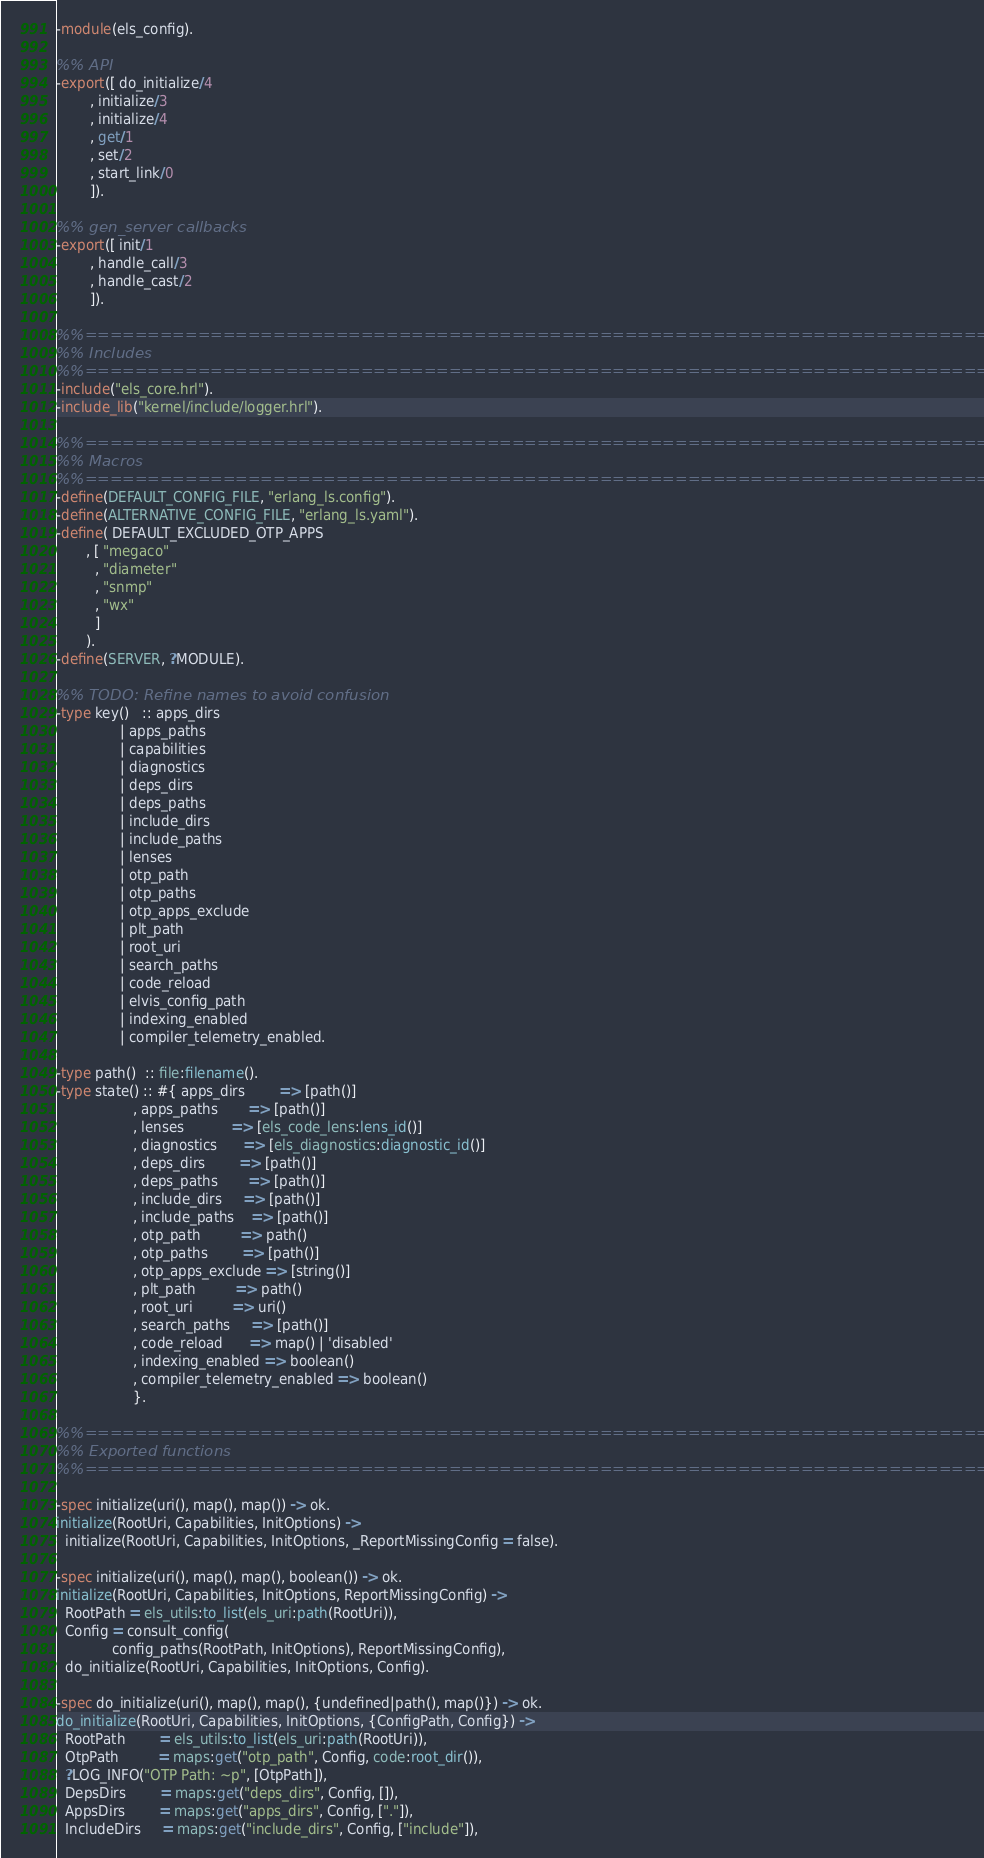Convert code to text. <code><loc_0><loc_0><loc_500><loc_500><_Erlang_>-module(els_config).

%% API
-export([ do_initialize/4
        , initialize/3
        , initialize/4
        , get/1
        , set/2
        , start_link/0
        ]).

%% gen_server callbacks
-export([ init/1
        , handle_call/3
        , handle_cast/2
        ]).

%%==============================================================================
%% Includes
%%==============================================================================
-include("els_core.hrl").
-include_lib("kernel/include/logger.hrl").

%%==============================================================================
%% Macros
%%==============================================================================
-define(DEFAULT_CONFIG_FILE, "erlang_ls.config").
-define(ALTERNATIVE_CONFIG_FILE, "erlang_ls.yaml").
-define( DEFAULT_EXCLUDED_OTP_APPS
       , [ "megaco"
         , "diameter"
         , "snmp"
         , "wx"
         ]
       ).
-define(SERVER, ?MODULE).

%% TODO: Refine names to avoid confusion
-type key()   :: apps_dirs
               | apps_paths
               | capabilities
               | diagnostics
               | deps_dirs
               | deps_paths
               | include_dirs
               | include_paths
               | lenses
               | otp_path
               | otp_paths
               | otp_apps_exclude
               | plt_path
               | root_uri
               | search_paths
               | code_reload
               | elvis_config_path
               | indexing_enabled
               | compiler_telemetry_enabled.

-type path()  :: file:filename().
-type state() :: #{ apps_dirs        => [path()]
                  , apps_paths       => [path()]
                  , lenses           => [els_code_lens:lens_id()]
                  , diagnostics      => [els_diagnostics:diagnostic_id()]
                  , deps_dirs        => [path()]
                  , deps_paths       => [path()]
                  , include_dirs     => [path()]
                  , include_paths    => [path()]
                  , otp_path         => path()
                  , otp_paths        => [path()]
                  , otp_apps_exclude => [string()]
                  , plt_path         => path()
                  , root_uri         => uri()
                  , search_paths     => [path()]
                  , code_reload      => map() | 'disabled'
                  , indexing_enabled => boolean()
                  , compiler_telemetry_enabled => boolean()
                  }.

%%==============================================================================
%% Exported functions
%%==============================================================================

-spec initialize(uri(), map(), map()) -> ok.
initialize(RootUri, Capabilities, InitOptions) ->
  initialize(RootUri, Capabilities, InitOptions, _ReportMissingConfig = false).

-spec initialize(uri(), map(), map(), boolean()) -> ok.
initialize(RootUri, Capabilities, InitOptions, ReportMissingConfig) ->
  RootPath = els_utils:to_list(els_uri:path(RootUri)),
  Config = consult_config(
             config_paths(RootPath, InitOptions), ReportMissingConfig),
  do_initialize(RootUri, Capabilities, InitOptions, Config).

-spec do_initialize(uri(), map(), map(), {undefined|path(), map()}) -> ok.
do_initialize(RootUri, Capabilities, InitOptions, {ConfigPath, Config}) ->
  RootPath        = els_utils:to_list(els_uri:path(RootUri)),
  OtpPath         = maps:get("otp_path", Config, code:root_dir()),
  ?LOG_INFO("OTP Path: ~p", [OtpPath]),
  DepsDirs        = maps:get("deps_dirs", Config, []),
  AppsDirs        = maps:get("apps_dirs", Config, ["."]),
  IncludeDirs     = maps:get("include_dirs", Config, ["include"]),</code> 